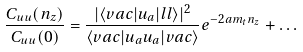<formula> <loc_0><loc_0><loc_500><loc_500>\frac { C _ { u u } ( n _ { z } ) } { C _ { u u } ( 0 ) } = \frac { | { \langle v a c | u _ { a } | l l \rangle } | ^ { 2 } } { \langle v a c | u _ { a } u _ { a } | v a c \rangle } e ^ { - 2 a m _ { t } n _ { z } } + \dots</formula> 